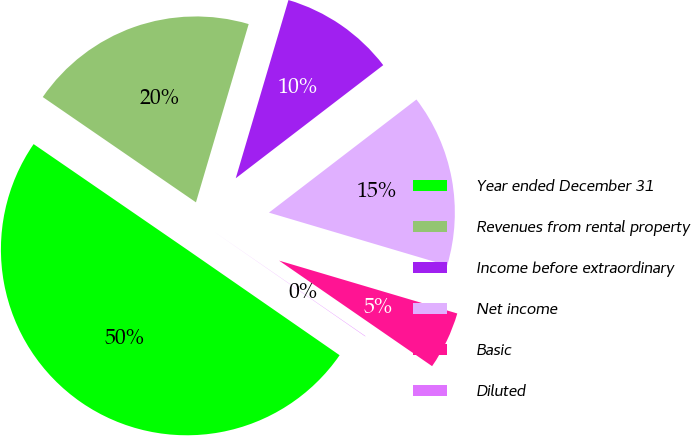<chart> <loc_0><loc_0><loc_500><loc_500><pie_chart><fcel>Year ended December 31<fcel>Revenues from rental property<fcel>Income before extraordinary<fcel>Net income<fcel>Basic<fcel>Diluted<nl><fcel>49.94%<fcel>19.99%<fcel>10.01%<fcel>15.0%<fcel>5.02%<fcel>0.03%<nl></chart> 